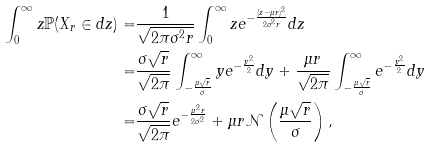<formula> <loc_0><loc_0><loc_500><loc_500>\int _ { 0 } ^ { \infty } z \mathbb { P } ( X _ { r } \in d z ) = & \frac { 1 } { \sqrt { 2 \pi \sigma ^ { 2 } r } } \int _ { 0 } ^ { \infty } z e ^ { - \frac { ( z - \mu r ) ^ { 2 } } { 2 \sigma ^ { 2 } r } } d z \\ = & \frac { \sigma \sqrt { r } } { \sqrt { 2 \pi } } \int _ { - \frac { \mu \sqrt { r } } { \sigma } } ^ { \infty } y e ^ { - \frac { y ^ { 2 } } { 2 } } d y + \frac { \mu r } { \sqrt { 2 \pi } } \int _ { - \frac { \mu \sqrt { r } } { \sigma } } ^ { \infty } e ^ { - \frac { y ^ { 2 } } { 2 } } d y \\ = & \frac { \sigma \sqrt { r } } { \sqrt { 2 \pi } } e ^ { - \frac { \mu ^ { 2 } r } { 2 \sigma ^ { 2 } } } + \mu r \mathcal { N } \left ( \frac { \mu \sqrt { r } } { \sigma } \right ) ,</formula> 